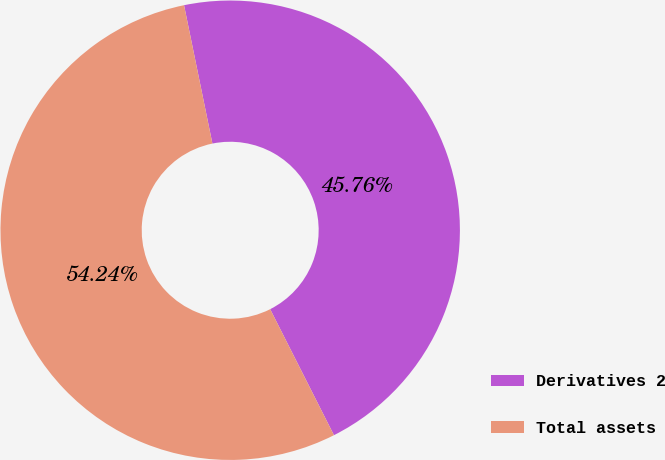Convert chart to OTSL. <chart><loc_0><loc_0><loc_500><loc_500><pie_chart><fcel>Derivatives 2<fcel>Total assets<nl><fcel>45.76%<fcel>54.24%<nl></chart> 